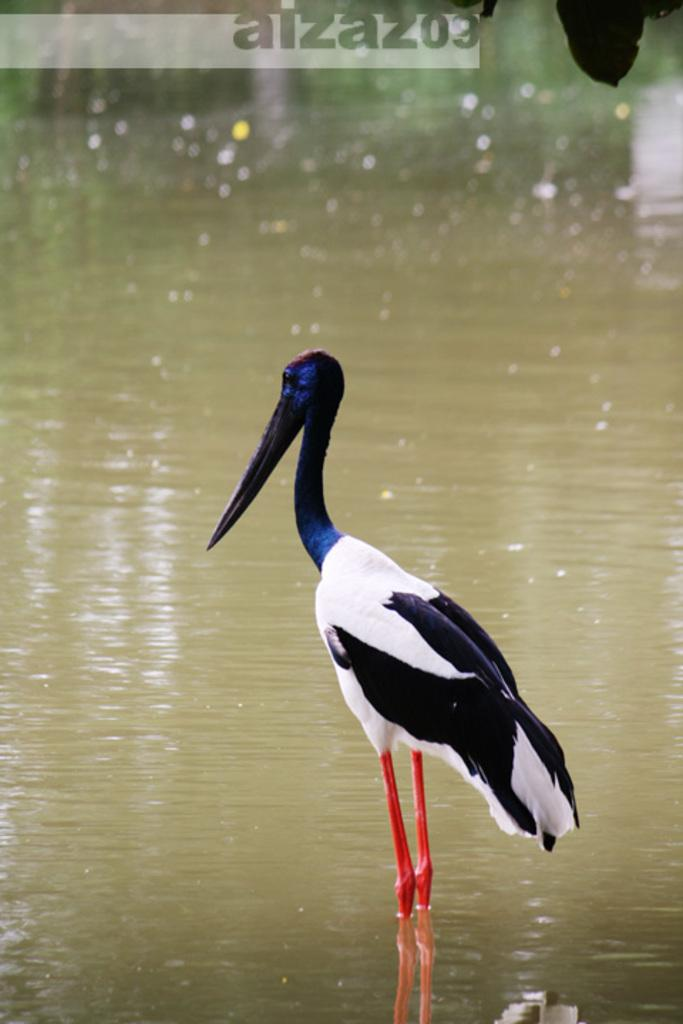What type of bird is in the water in the image? There is a white stork bird in the water in the image. Can you describe any text that is present in the image? There is some text at the top of the image. How many payments are being made by the sock in the image? There is no sock present in the image, and therefore no payments can be made. 